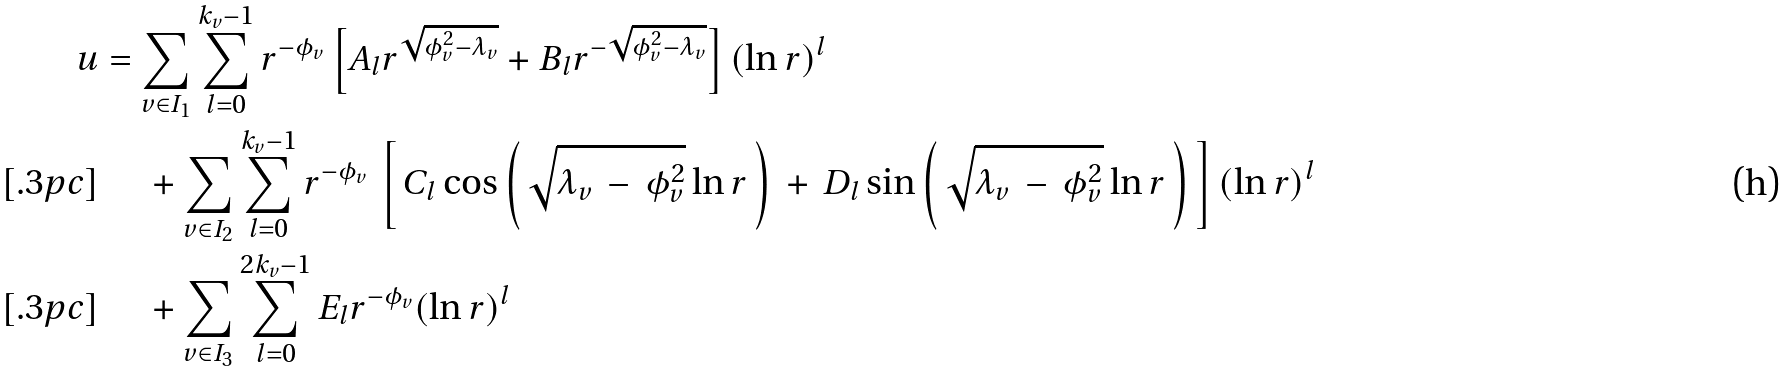Convert formula to latex. <formula><loc_0><loc_0><loc_500><loc_500>u & = \sum _ { v \in I _ { 1 } } \sum _ { l = 0 } ^ { k _ { v } - 1 } r ^ { - \phi _ { v } } \left [ A _ { l } r ^ { \sqrt { \phi _ { v } ^ { 2 } - \lambda _ { v } } } + B _ { l } r ^ { - \sqrt { \phi _ { v } ^ { 2 } - \lambda _ { v } } } \right ] ( \ln r ) ^ { l } \\ [ . 3 p c ] & \quad \, + \sum _ { v \in I _ { 2 } } \sum _ { l = 0 } ^ { k _ { v } - 1 } r ^ { - \phi _ { v } } \, \left [ \, C _ { l } \cos \left ( \, \sqrt { \lambda _ { v } \, - \, \phi _ { v } ^ { 2 } } \ln r \, \right ) \, + \, D _ { l } \sin \left ( \, \sqrt { \lambda _ { v } \, - \, \phi _ { v } ^ { 2 } } \ln r \, \right ) \, \right ] ( \ln r ) ^ { l } \\ [ . 3 p c ] & \quad \, + \sum _ { v \in I _ { 3 } } \sum _ { l = 0 } ^ { 2 k _ { v } - 1 } E _ { l } r ^ { - \phi _ { v } } ( \ln r ) ^ { l }</formula> 